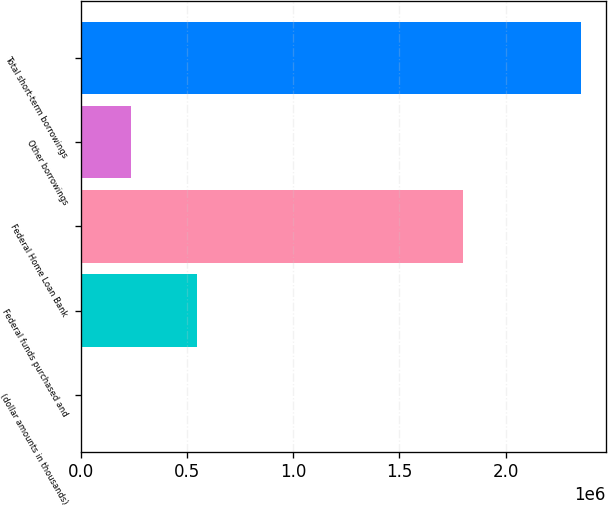<chart> <loc_0><loc_0><loc_500><loc_500><bar_chart><fcel>(dollar amounts in thousands)<fcel>Federal funds purchased and<fcel>Federal Home Loan Bank<fcel>Other borrowings<fcel>Total short-term borrowings<nl><fcel>2013<fcel>548605<fcel>1.8e+06<fcel>237026<fcel>2.35214e+06<nl></chart> 